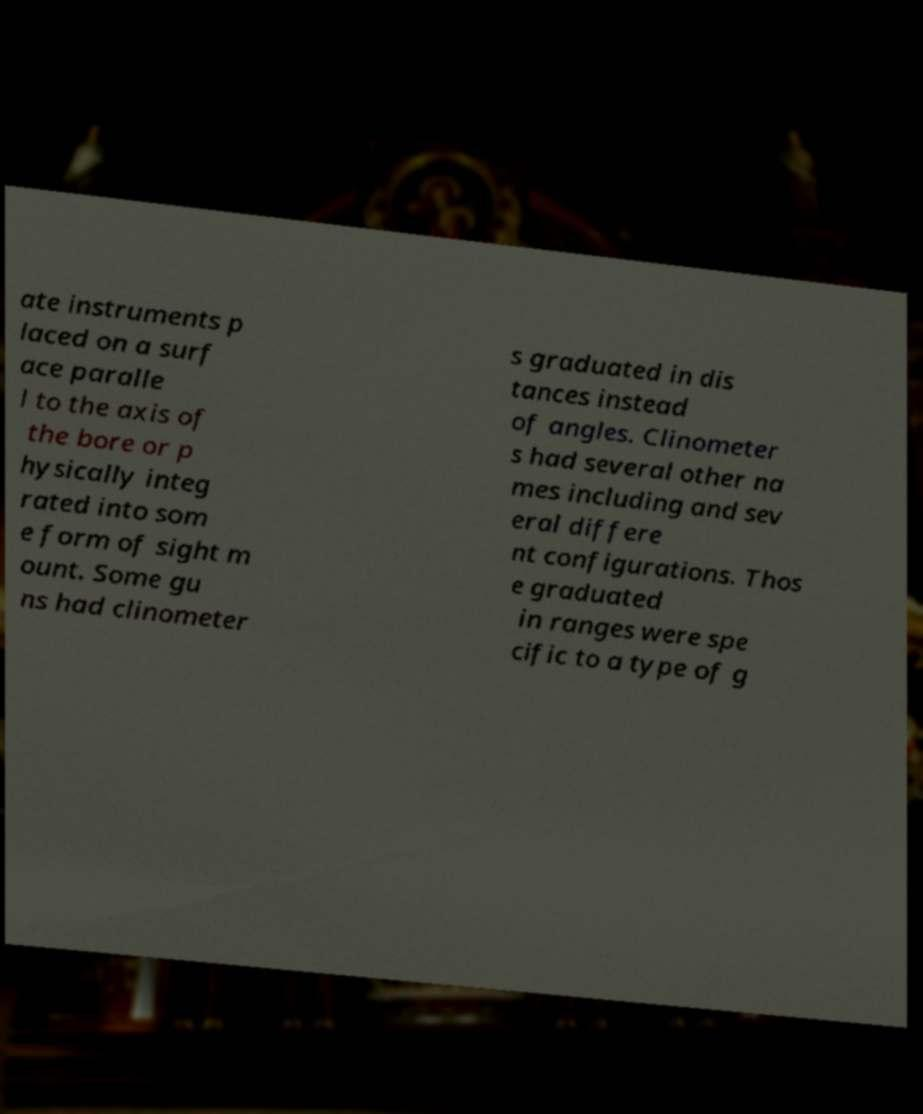Can you accurately transcribe the text from the provided image for me? ate instruments p laced on a surf ace paralle l to the axis of the bore or p hysically integ rated into som e form of sight m ount. Some gu ns had clinometer s graduated in dis tances instead of angles. Clinometer s had several other na mes including and sev eral differe nt configurations. Thos e graduated in ranges were spe cific to a type of g 